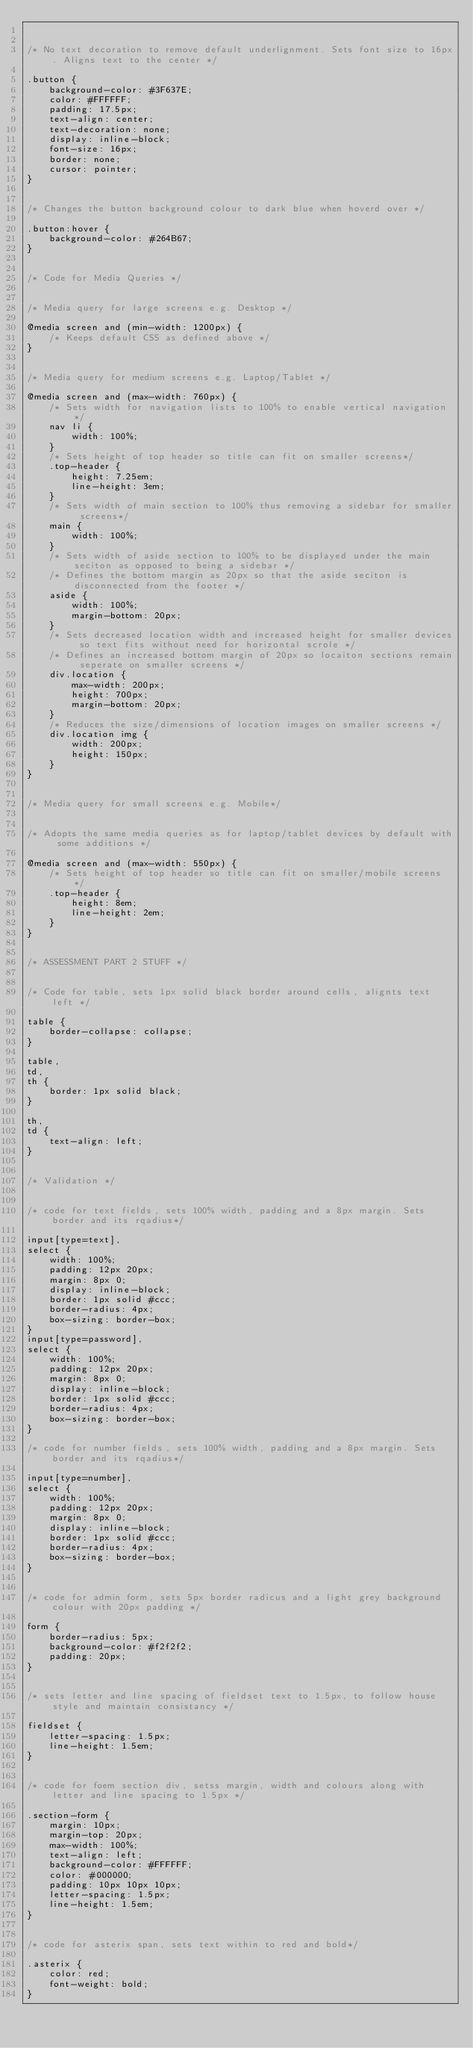Convert code to text. <code><loc_0><loc_0><loc_500><loc_500><_CSS_>

/* No text decoration to remove default underlignment. Sets font size to 16px. Aligns text to the center */

.button {
	background-color: #3F637E;
	color: #FFFFFF;
	padding: 17.5px;
	text-align: center;
	text-decoration: none;
	display: inline-block;
	font-size: 16px;
	border: none;
	cursor: pointer;
}


/* Changes the button background colour to dark blue when hoverd over */

.button:hover {
	background-color: #264B67;
}


/* Code for Media Queries */


/* Media query for large screens e.g. Desktop */

@media screen and (min-width: 1200px) {
	/* Keeps default CSS as defined above */
}


/* Media query for medium screens e.g. Laptop/Tablet */

@media screen and (max-width: 760px) {
	/* Sets width for navigation lists to 100% to enable vertical navigation */
	nav li {
		width: 100%;
	}
	/* Sets height of top header so title can fit on smaller screens*/
	.top-header {
		height: 7.25em;
		line-height: 3em;
	}
	/* Sets width of main section to 100% thus removing a sidebar for smaller screens*/
	main {
		width: 100%;
	}
	/* Sets width of aside section to 100% to be displayed under the main seciton as opposed to being a sidebar */
	/* Defines the bottom margin as 20px so that the aside seciton is disconnected from the footer */
	aside {
		width: 100%;
		margin-bottom: 20px;
	}
	/* Sets decreased location width and increased height for smaller devices so text fits without need for horizontal scrole */
	/* Defines an increased bottom margin of 20px so locaiton sections remain seperate on smaller screens */
	div.location {
		max-width: 200px;
		height: 700px;
		margin-bottom: 20px;
	}
	/* Reduces the size/dimensions of location images on smaller screens */
	div.location img {
		width: 200px;
		height: 150px;
	}
}


/* Media query for small screens e.g. Mobile*/


/* Adopts the same media queries as for laptop/tablet devices by default with some additions */

@media screen and (max-width: 550px) {
	/* Sets height of top header so title can fit on smaller/mobile screens */
	.top-header {
		height: 8em;
		line-height: 2em;
	}
}


/* ASSESSMENT PART 2 STUFF */


/* Code for table, sets 1px solid black border around cells, alignts text left */

table {
	border-collapse: collapse;
}

table,
td,
th {
	border: 1px solid black;
}

th,
td {
	text-align: left;
}


/* Validation */


/* code for text fields, sets 100% width, padding and a 8px margin. Sets border and its rqadius*/

input[type=text],
select {
	width: 100%;
	padding: 12px 20px;
	margin: 8px 0;
	display: inline-block;
	border: 1px solid #ccc;
	border-radius: 4px;
	box-sizing: border-box;
}
input[type=password],
select {
	width: 100%;
	padding: 12px 20px;
	margin: 8px 0;
	display: inline-block;
	border: 1px solid #ccc;
	border-radius: 4px;
	box-sizing: border-box;
}

/* code for number fields, sets 100% width, padding and a 8px margin. Sets border and its rqadius*/

input[type=number],
select {
	width: 100%;
	padding: 12px 20px;
	margin: 8px 0;
	display: inline-block;
	border: 1px solid #ccc;
	border-radius: 4px;
	box-sizing: border-box;
}


/* code for admin form, sets 5px border radicus and a light grey background colour with 20px padding */

form {
	border-radius: 5px;
	background-color: #f2f2f2;
	padding: 20px;
}


/* sets letter and line spacing of fieldset text to 1.5px, to follow house style and maintain consistancy */

fieldset {
	letter-spacing: 1.5px;
	line-height: 1.5em;
}


/* code for foem section div, setss margin, width and colours along with letter and line spacing to 1.5px */

.section-form {
	margin: 10px;
	margin-top: 20px;
	max-width: 100%;
	text-align: left;
	background-color: #FFFFFF;
	color: #000000;
	padding: 10px 10px 10px;
	letter-spacing: 1.5px;
	line-height: 1.5em;
}


/* code for asterix span, sets text within to red and bold*/

.asterix {
	color: red;
	font-weight: bold;
}
</code> 